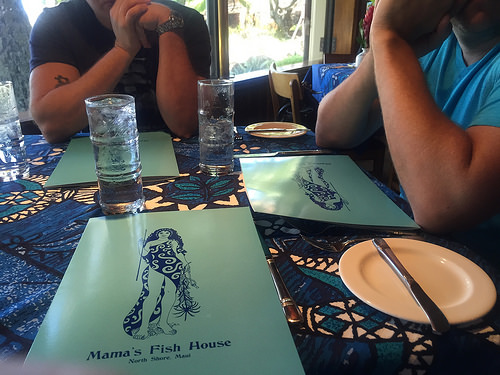<image>
Is the woman on the menu? Yes. Looking at the image, I can see the woman is positioned on top of the menu, with the menu providing support. Is there a glass next to the tablecloth? No. The glass is not positioned next to the tablecloth. They are located in different areas of the scene. 